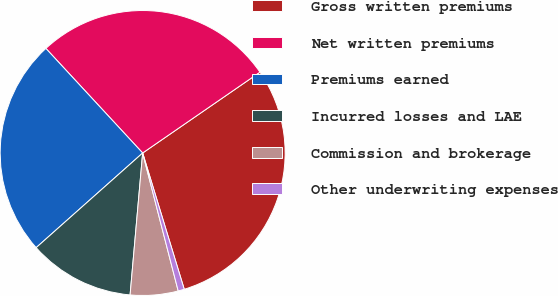Convert chart. <chart><loc_0><loc_0><loc_500><loc_500><pie_chart><fcel>Gross written premiums<fcel>Net written premiums<fcel>Premiums earned<fcel>Incurred losses and LAE<fcel>Commission and brokerage<fcel>Other underwriting expenses<nl><fcel>29.89%<fcel>27.28%<fcel>24.68%<fcel>12.03%<fcel>5.42%<fcel>0.7%<nl></chart> 